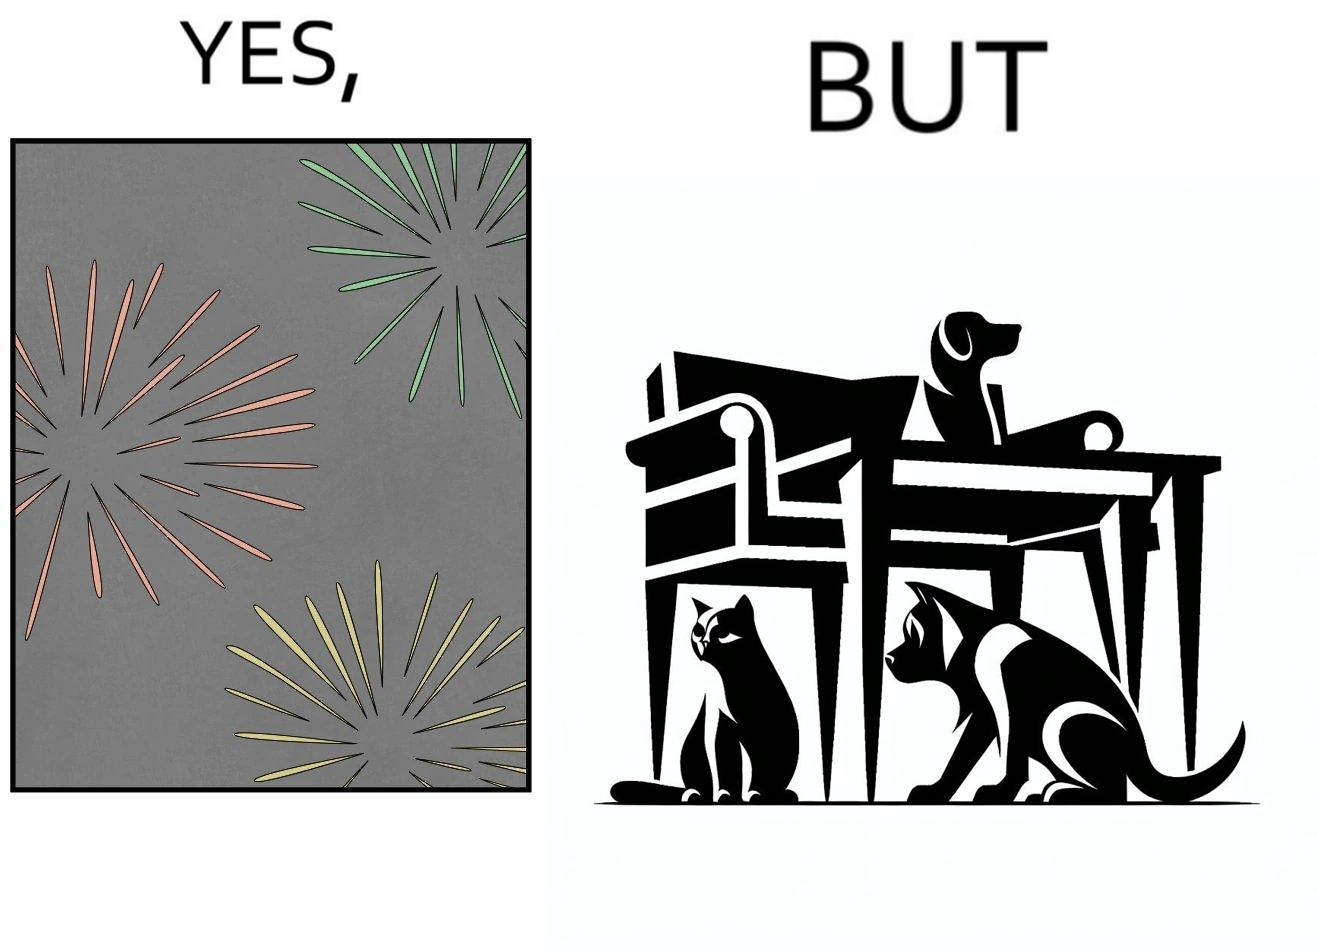Compare the left and right sides of this image. In the left part of the image: The image shows colorful firecrackers going off in the sky. In the right part of the image: The image shows two dogs and a cat hiding under furniture. 